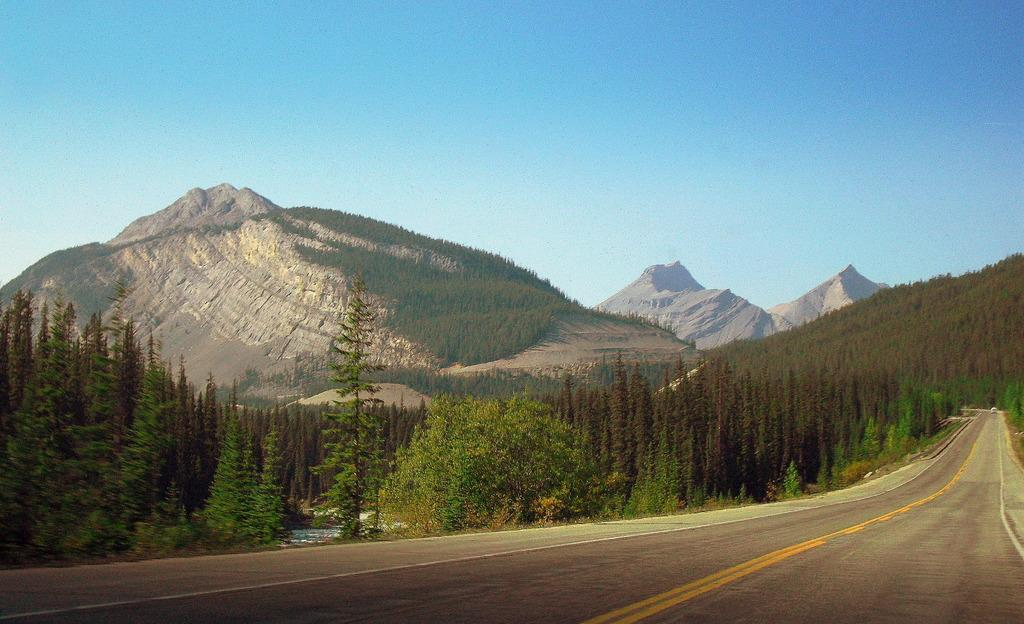What is located on the pathway in the image? There is a vehicle on the pathway in the image. What type of natural scenery can be seen in the image? There is a group of trees and hills visible in the image. What is visible in the background of the image? The sky is visible in the image. How would you describe the weather based on the appearance of the sky? The sky appears cloudy in the image. What type of loaf is being used in the image? There is no loaf or system in the image; it features a vehicle on a pathway with natural scenery and a cloudy sky. 